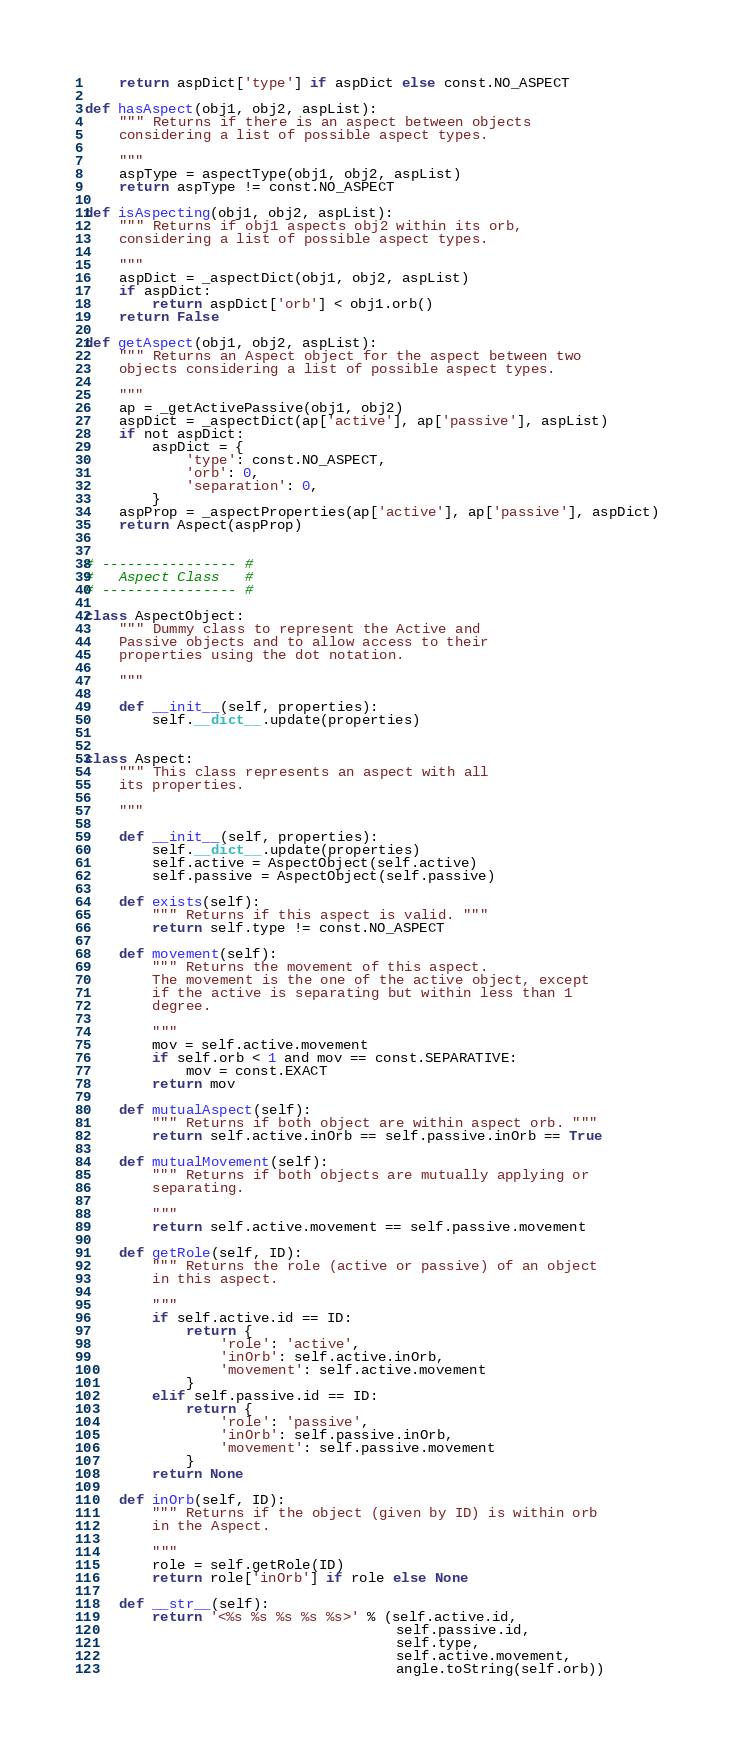Convert code to text. <code><loc_0><loc_0><loc_500><loc_500><_Python_>    return aspDict['type'] if aspDict else const.NO_ASPECT

def hasAspect(obj1, obj2, aspList):
    """ Returns if there is an aspect between objects 
    considering a list of possible aspect types.
    
    """
    aspType = aspectType(obj1, obj2, aspList)
    return aspType != const.NO_ASPECT

def isAspecting(obj1, obj2, aspList):
    """ Returns if obj1 aspects obj2 within its orb,
    considering a list of possible aspect types. 
    
    """
    aspDict = _aspectDict(obj1, obj2, aspList)
    if aspDict:
        return aspDict['orb'] < obj1.orb()
    return False

def getAspect(obj1, obj2, aspList):
    """ Returns an Aspect object for the aspect between two
    objects considering a list of possible aspect types.
    
    """
    ap = _getActivePassive(obj1, obj2)
    aspDict = _aspectDict(ap['active'], ap['passive'], aspList)
    if not aspDict:
        aspDict = {
            'type': const.NO_ASPECT,
            'orb': 0,
            'separation': 0,
        } 
    aspProp = _aspectProperties(ap['active'], ap['passive'], aspDict)
    return Aspect(aspProp)


# ---------------- #
#   Aspect Class   #
# ---------------- #

class AspectObject:
    """ Dummy class to represent the Active and
    Passive objects and to allow access to their
    properties using the dot notation.
    
    """
    
    def __init__(self, properties):
        self.__dict__.update(properties)
        

class Aspect:
    """ This class represents an aspect with all
    its properties.
    
    """
    
    def __init__(self, properties):
        self.__dict__.update(properties)
        self.active = AspectObject(self.active)
        self.passive = AspectObject(self.passive)

    def exists(self):
        """ Returns if this aspect is valid. """
        return self.type != const.NO_ASPECT
    
    def movement(self):
        """ Returns the movement of this aspect. 
        The movement is the one of the active object, except
        if the active is separating but within less than 1 
        degree.
        
        """
        mov = self.active.movement
        if self.orb < 1 and mov == const.SEPARATIVE:
            mov = const.EXACT
        return mov
    
    def mutualAspect(self):
        """ Returns if both object are within aspect orb. """
        return self.active.inOrb == self.passive.inOrb == True
    
    def mutualMovement(self):
        """ Returns if both objects are mutually applying or
        separating.
        
        """
        return self.active.movement == self.passive.movement
    
    def getRole(self, ID):
        """ Returns the role (active or passive) of an object
        in this aspect.
        
        """
        if self.active.id == ID:
            return {
                'role': 'active',
                'inOrb': self.active.inOrb,
                'movement': self.active.movement
            }
        elif self.passive.id == ID:
            return {
                'role': 'passive',
                'inOrb': self.passive.inOrb,
                'movement': self.passive.movement
            }
        return None
    
    def inOrb(self, ID):
        """ Returns if the object (given by ID) is within orb
        in the Aspect.
        
        """
        role = self.getRole(ID)
        return role['inOrb'] if role else None
    
    def __str__(self):
        return '<%s %s %s %s %s>' % (self.active.id,
                                     self.passive.id,
                                     self.type,
                                     self.active.movement,
                                     angle.toString(self.orb))</code> 